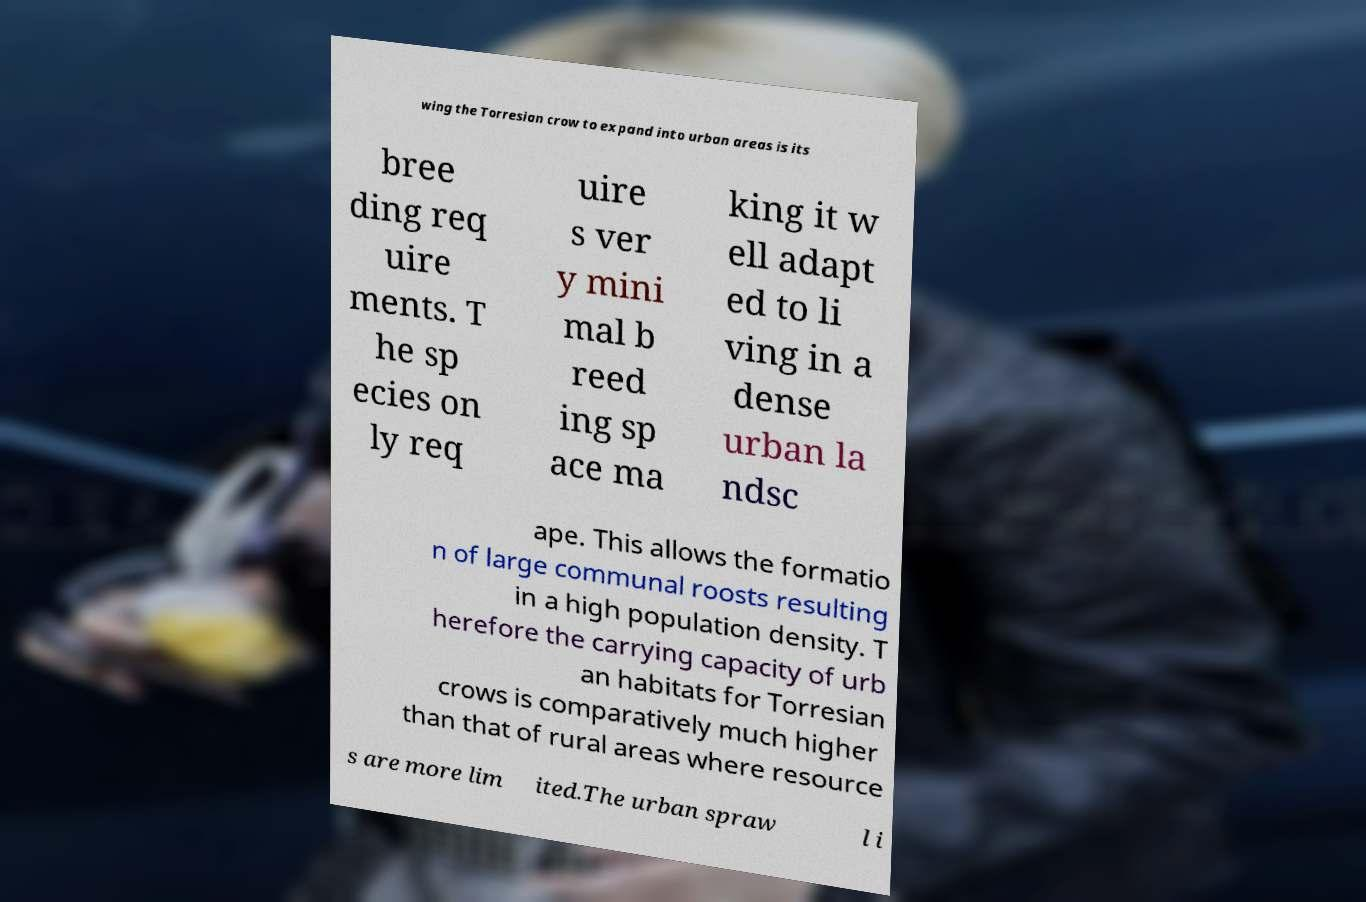Please identify and transcribe the text found in this image. wing the Torresian crow to expand into urban areas is its bree ding req uire ments. T he sp ecies on ly req uire s ver y mini mal b reed ing sp ace ma king it w ell adapt ed to li ving in a dense urban la ndsc ape. This allows the formatio n of large communal roosts resulting in a high population density. T herefore the carrying capacity of urb an habitats for Torresian crows is comparatively much higher than that of rural areas where resource s are more lim ited.The urban spraw l i 